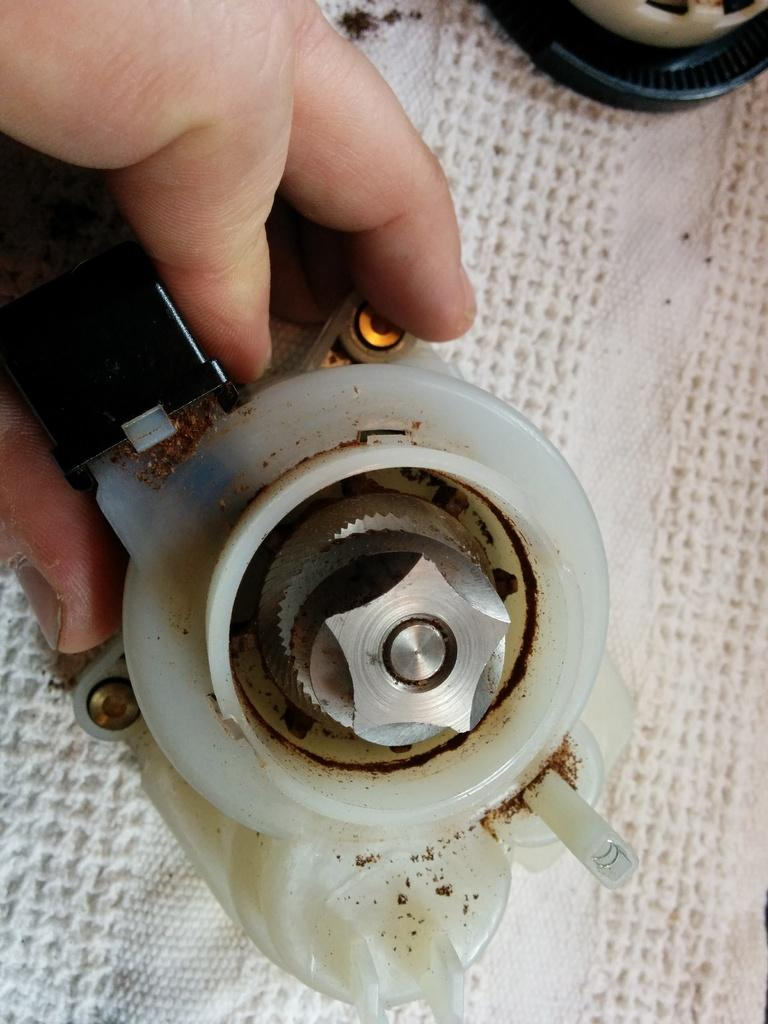What is the person's hand holding in the image? There is an object being held by the person's hand in the image. What type of material is at the bottom of the image? There is cloth at the bottom of the image. Can you see a knife being used by the person in the image? There is no knife visible in the image. Is there a bike present in the image? There is no bike present in the image. 